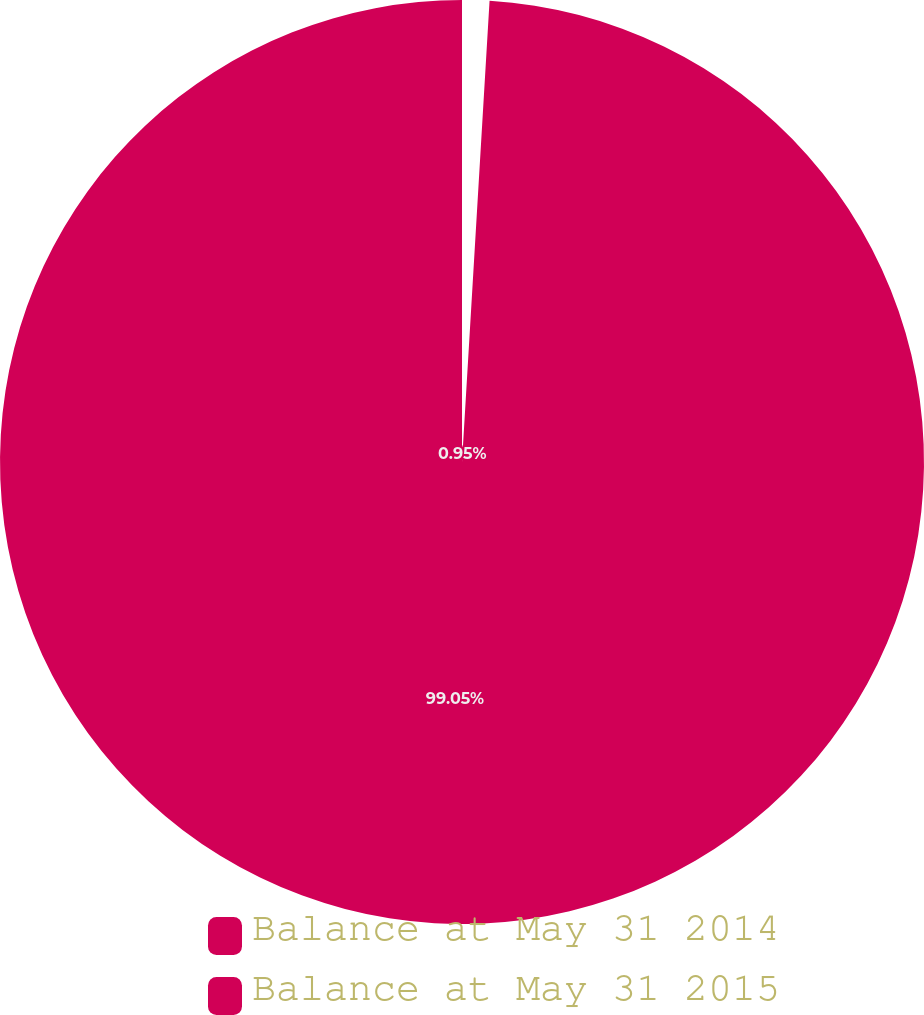<chart> <loc_0><loc_0><loc_500><loc_500><pie_chart><fcel>Balance at May 31 2014<fcel>Balance at May 31 2015<nl><fcel>0.95%<fcel>99.05%<nl></chart> 